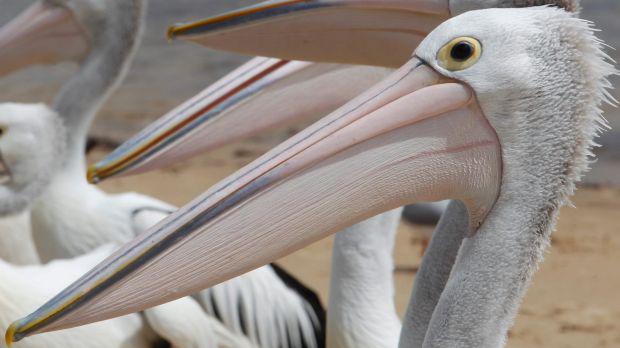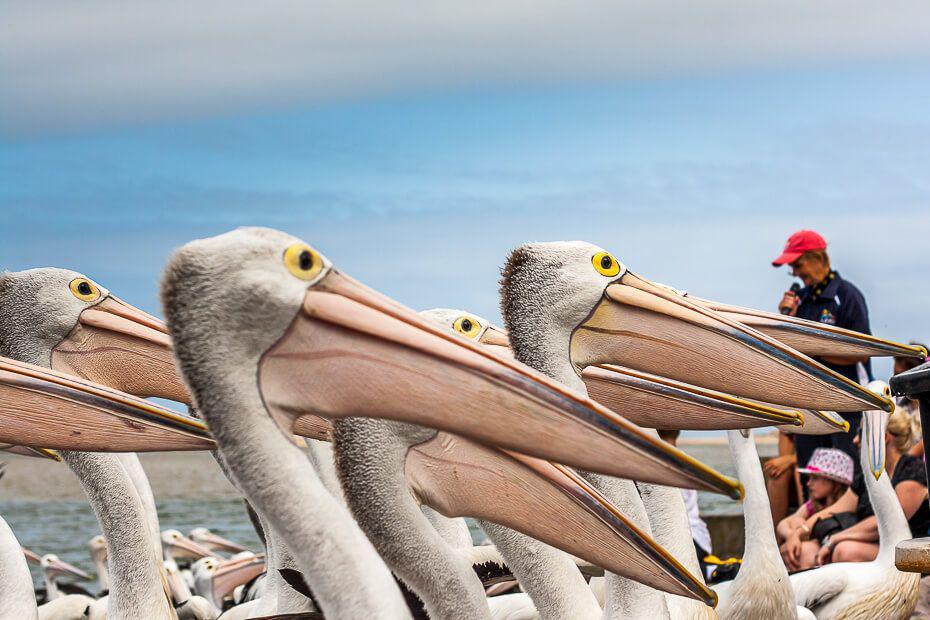The first image is the image on the left, the second image is the image on the right. Considering the images on both sides, is "In at least one of the images, every single bird is facing to the left." valid? Answer yes or no. Yes. The first image is the image on the left, the second image is the image on the right. Examine the images to the left and right. Is the description "There are at least eight pelicans facing left with no more than four people visible in the right side of the photo." accurate? Answer yes or no. Yes. 